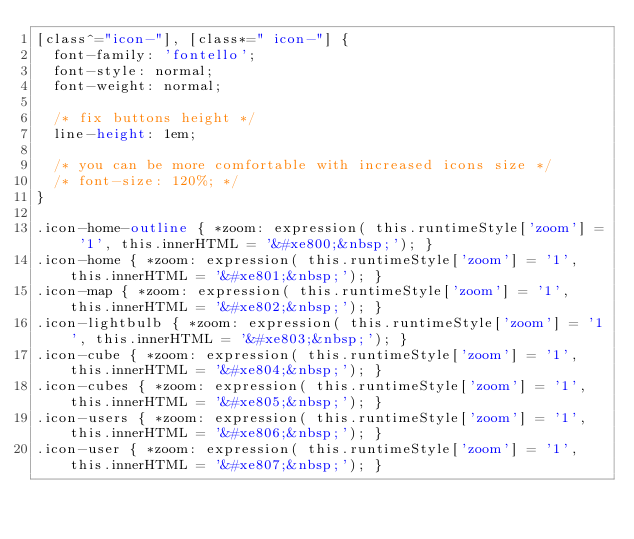<code> <loc_0><loc_0><loc_500><loc_500><_CSS_>[class^="icon-"], [class*=" icon-"] {
  font-family: 'fontello';
  font-style: normal;
  font-weight: normal;
 
  /* fix buttons height */
  line-height: 1em;
 
  /* you can be more comfortable with increased icons size */
  /* font-size: 120%; */
}
 
.icon-home-outline { *zoom: expression( this.runtimeStyle['zoom'] = '1', this.innerHTML = '&#xe800;&nbsp;'); }
.icon-home { *zoom: expression( this.runtimeStyle['zoom'] = '1', this.innerHTML = '&#xe801;&nbsp;'); }
.icon-map { *zoom: expression( this.runtimeStyle['zoom'] = '1', this.innerHTML = '&#xe802;&nbsp;'); }
.icon-lightbulb { *zoom: expression( this.runtimeStyle['zoom'] = '1', this.innerHTML = '&#xe803;&nbsp;'); }
.icon-cube { *zoom: expression( this.runtimeStyle['zoom'] = '1', this.innerHTML = '&#xe804;&nbsp;'); }
.icon-cubes { *zoom: expression( this.runtimeStyle['zoom'] = '1', this.innerHTML = '&#xe805;&nbsp;'); }
.icon-users { *zoom: expression( this.runtimeStyle['zoom'] = '1', this.innerHTML = '&#xe806;&nbsp;'); }
.icon-user { *zoom: expression( this.runtimeStyle['zoom'] = '1', this.innerHTML = '&#xe807;&nbsp;'); }</code> 